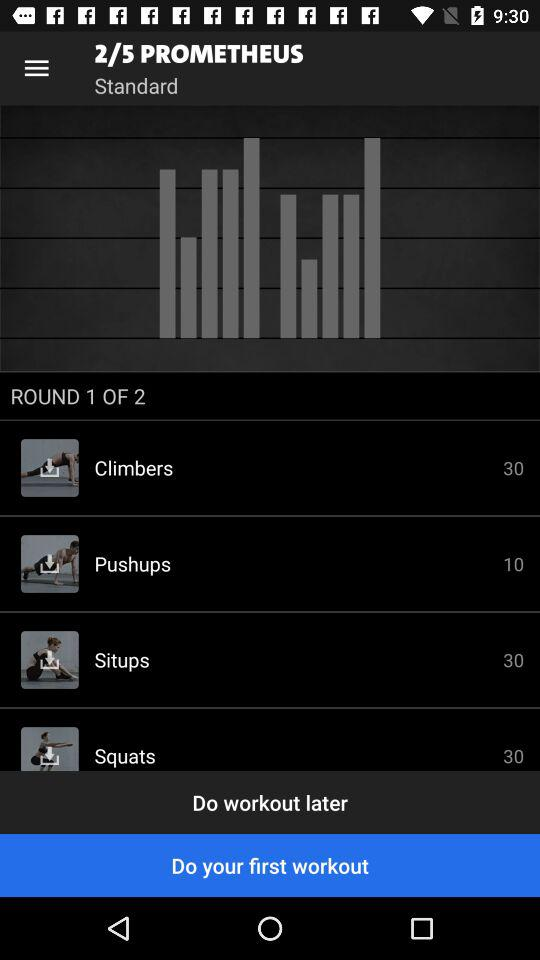Which one is selected, "Do workout later" or "Do your first workout"? The selected one is "Do your first workout". 